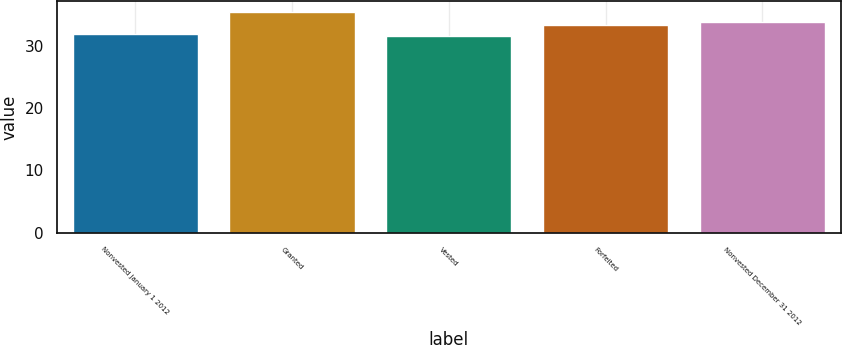<chart> <loc_0><loc_0><loc_500><loc_500><bar_chart><fcel>Nonvested January 1 2012<fcel>Granted<fcel>Vested<fcel>Forfeited<fcel>Nonvested December 31 2012<nl><fcel>31.9<fcel>35.35<fcel>31.52<fcel>33.38<fcel>33.78<nl></chart> 